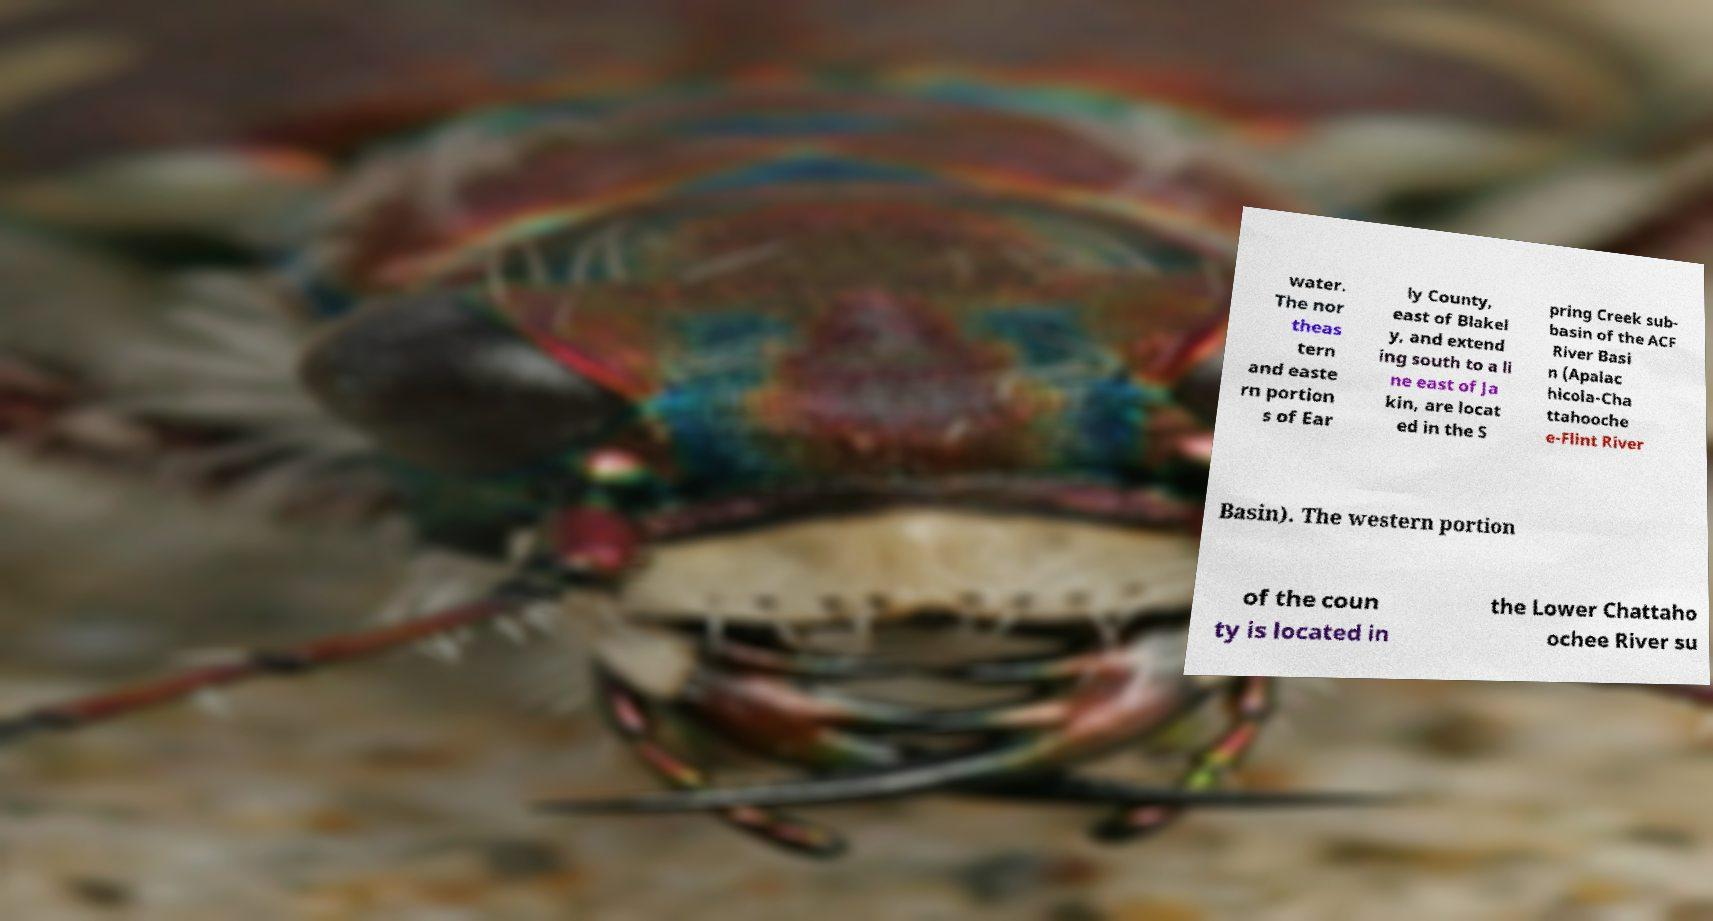Can you accurately transcribe the text from the provided image for me? water. The nor theas tern and easte rn portion s of Ear ly County, east of Blakel y, and extend ing south to a li ne east of Ja kin, are locat ed in the S pring Creek sub- basin of the ACF River Basi n (Apalac hicola-Cha ttahooche e-Flint River Basin). The western portion of the coun ty is located in the Lower Chattaho ochee River su 